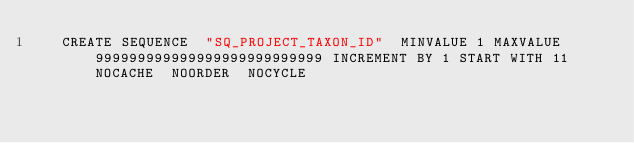Convert code to text. <code><loc_0><loc_0><loc_500><loc_500><_SQL_>   CREATE SEQUENCE  "SQ_PROJECT_TAXON_ID"  MINVALUE 1 MAXVALUE 999999999999999999999999999 INCREMENT BY 1 START WITH 11 NOCACHE  NOORDER  NOCYCLE </code> 